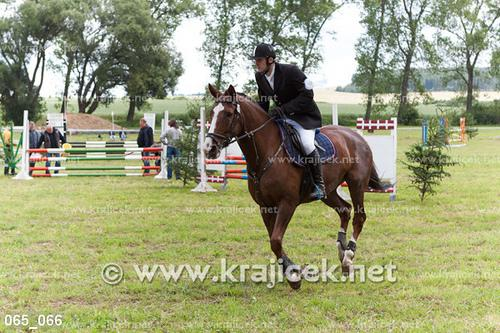Question: how many people are shown?
Choices:
A. Five.
B. Four.
C. Ten.
D. Twelve.
Answer with the letter. Answer: A Question: where is the photo taken?
Choices:
A. Football stadium.
B. High School.
C. Park.
D. Grass field.
Answer with the letter. Answer: D Question: what does the c surrounded by the circle stand for?
Choices:
A. Proprietary.
B. Trademark.
C. Right of first use.
D. Copyright.
Answer with the letter. Answer: D 